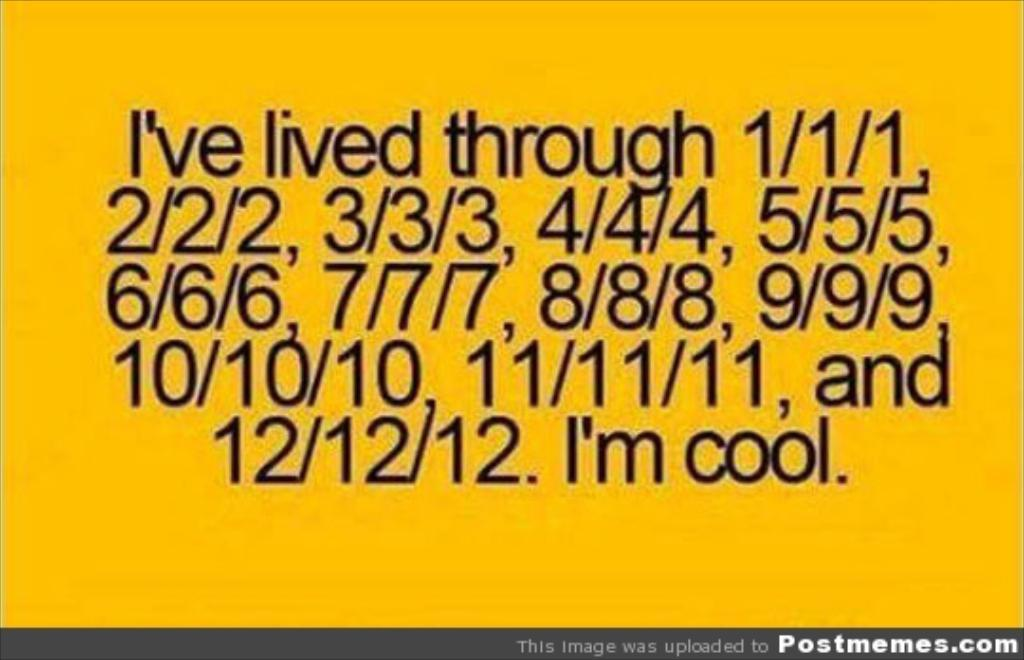What types of information can be found in the image? The image contains text and numbers. What color is the surface of the image? The surface of the image is yellow. Can you describe the alley in the image? There is no alley present in the image; it contains text, numbers, and a yellow surface. What type of flesh can be seen in the image? There is no flesh present in the image; it contains text, numbers, and a yellow surface. 